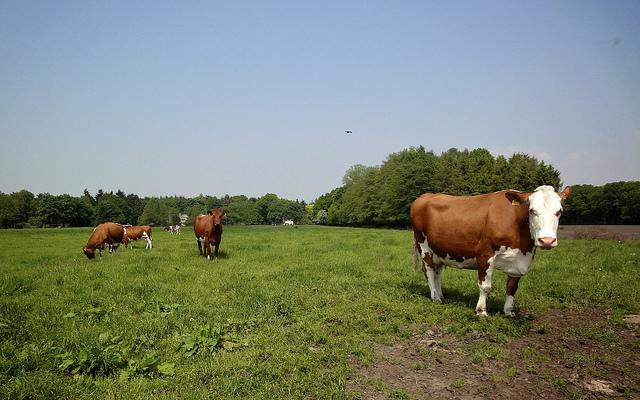How many cows are looking at the camera?

Choices:
A) one
B) four
C) two
D) three two 